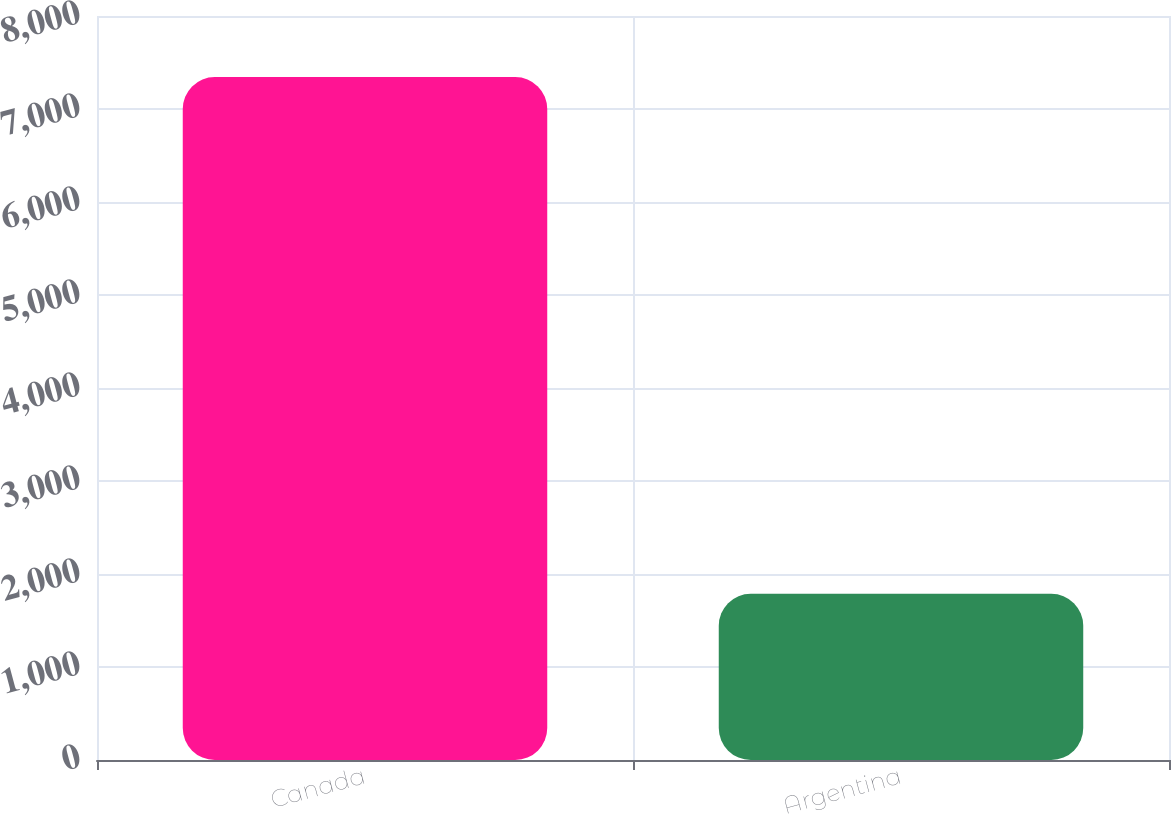<chart> <loc_0><loc_0><loc_500><loc_500><bar_chart><fcel>Canada<fcel>Argentina<nl><fcel>7344<fcel>1787<nl></chart> 